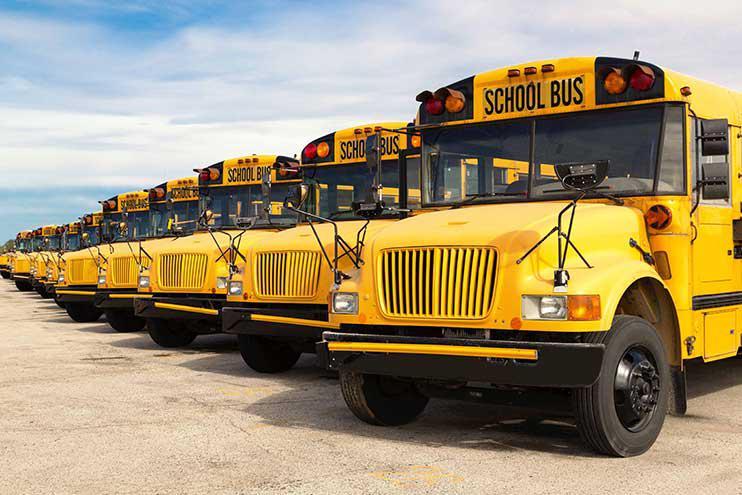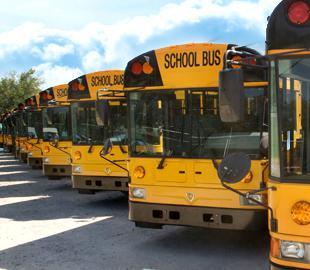The first image is the image on the left, the second image is the image on the right. For the images displayed, is the sentence "Some buses have front license plates." factually correct? Answer yes or no. No. The first image is the image on the left, the second image is the image on the right. Analyze the images presented: Is the assertion "At least one image shows buses with forward-turned non-flat fronts parked side-by-side in a row and angled facing rightward." valid? Answer yes or no. No. 